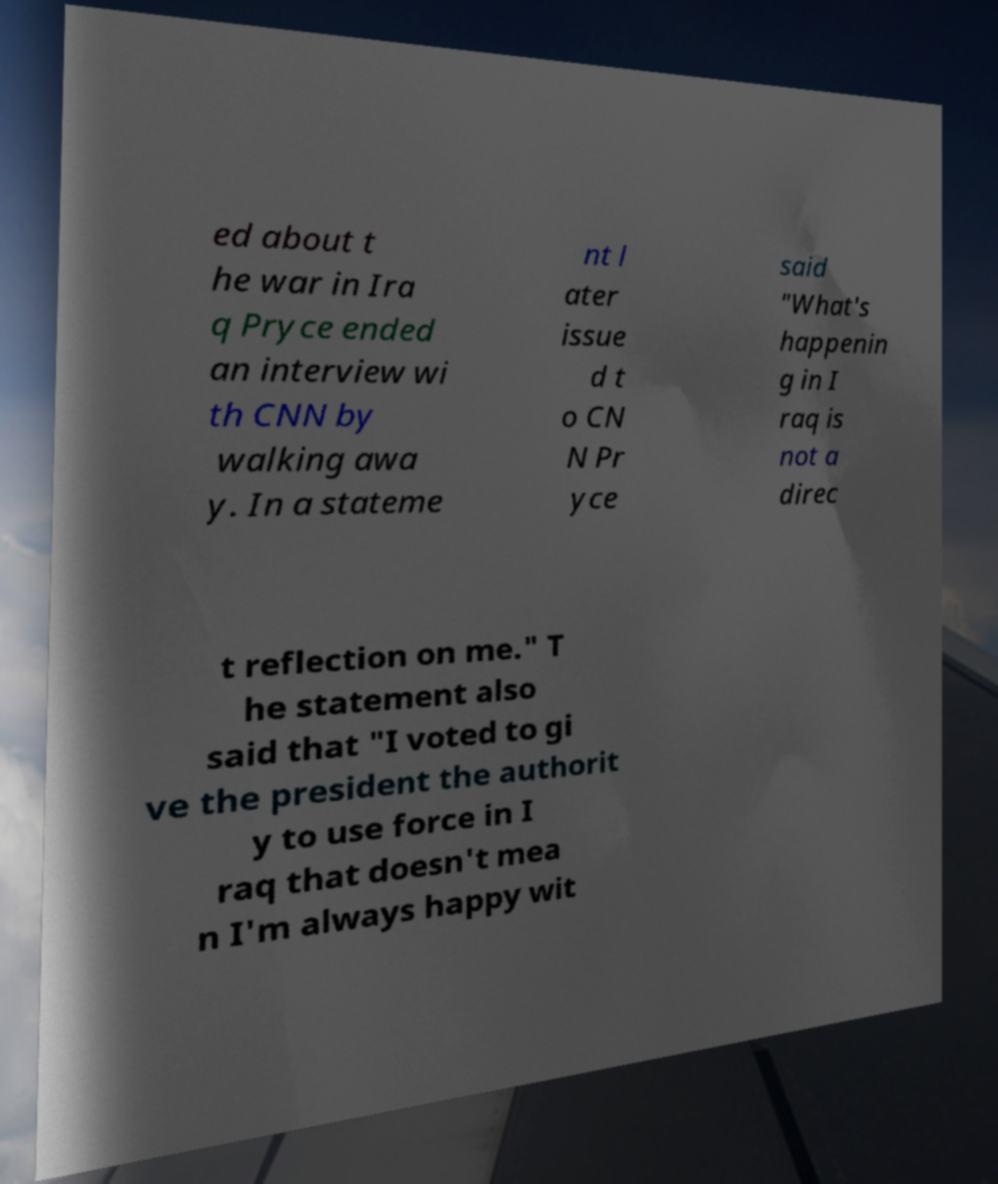I need the written content from this picture converted into text. Can you do that? ed about t he war in Ira q Pryce ended an interview wi th CNN by walking awa y. In a stateme nt l ater issue d t o CN N Pr yce said "What's happenin g in I raq is not a direc t reflection on me." T he statement also said that "I voted to gi ve the president the authorit y to use force in I raq that doesn't mea n I'm always happy wit 